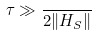Convert formula to latex. <formula><loc_0><loc_0><loc_500><loc_500>\tau \gg \frac { } { 2 \| H _ { S } \| }</formula> 